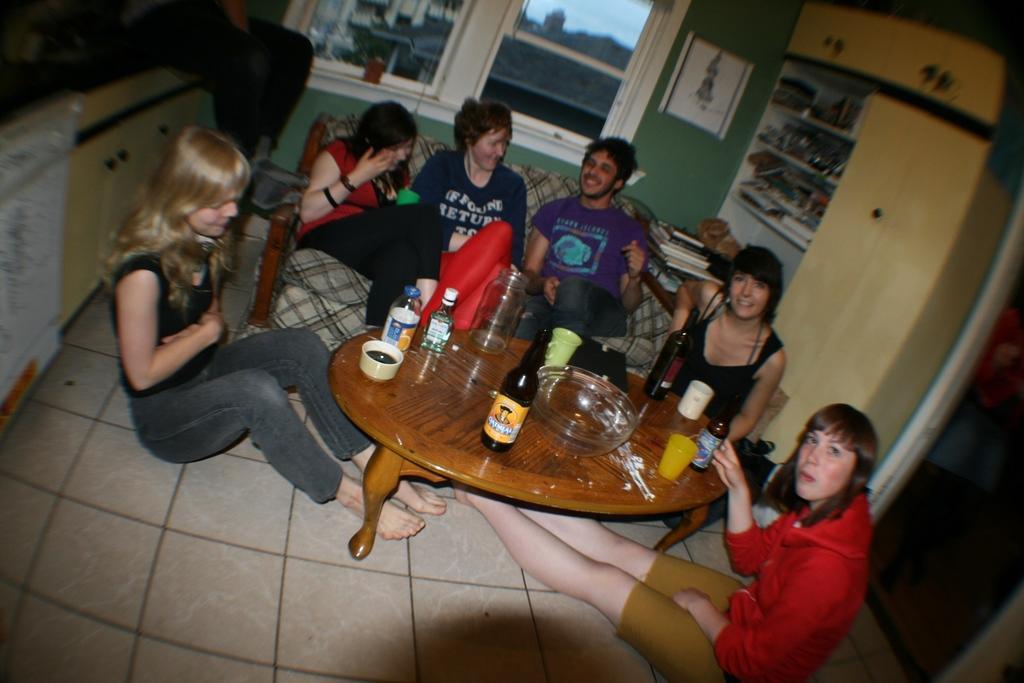Could you give a brief overview of what you see in this image? In this image i can see group of people some are sitting on chair and some are on floor, i can also see few bottles, and bowls on table at the back ground there is a wall and a window. 